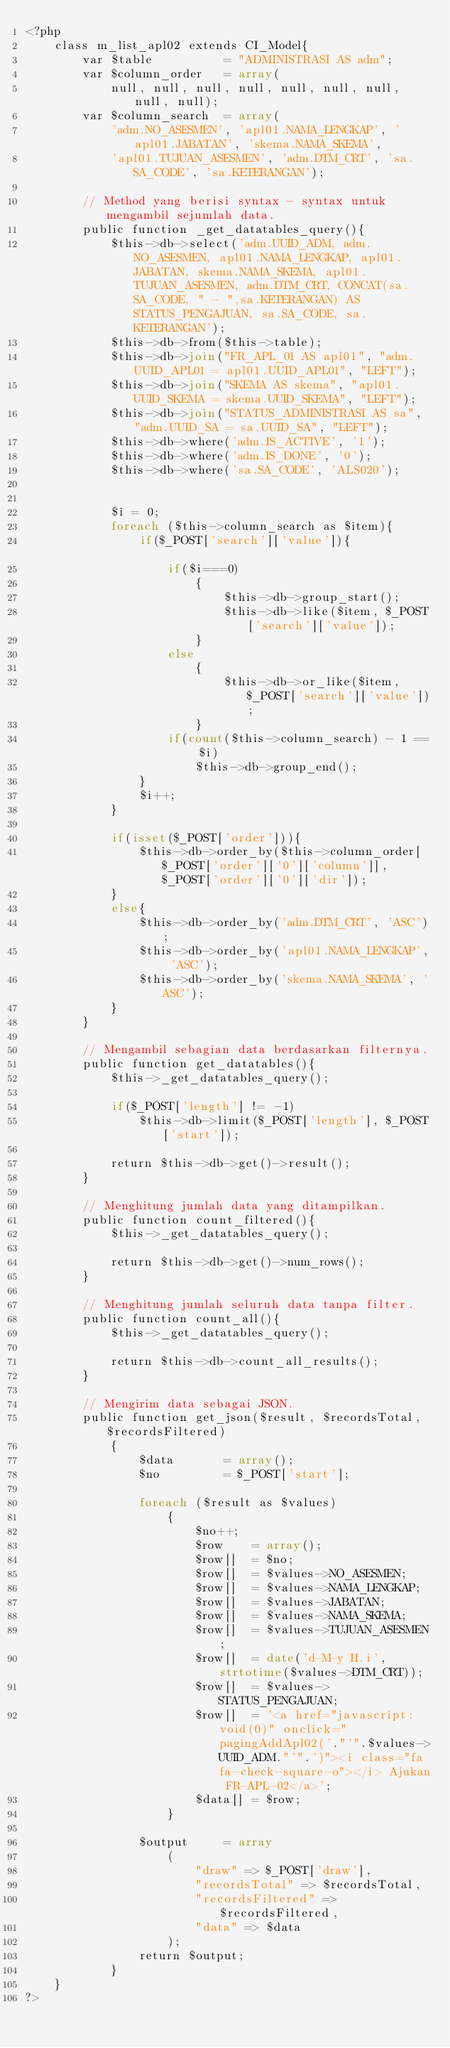<code> <loc_0><loc_0><loc_500><loc_500><_PHP_><?php
	class m_list_apl02 extends CI_Model{
		var $table			= "ADMINISTRASI AS adm";
		var $column_order	= array(
			null, null, null, null, null, null, null, null, null); 
		var $column_search	= array(
			'adm.NO_ASESMEN', 'apl01.NAMA_LENGKAP', 'apl01.JABATAN', 'skema.NAMA_SKEMA', 
			'apl01.TUJUAN_ASESMEN', 'adm.DTM_CRT', 'sa.SA_CODE', 'sa.KETERANGAN');
		
		// Method yang berisi syntax - syntax untuk mengambil sejumlah data.
		public function _get_datatables_query(){
			$this->db->select('adm.UUID_ADM, adm.NO_ASESMEN, apl01.NAMA_LENGKAP, apl01.JABATAN, skema.NAMA_SKEMA, apl01.TUJUAN_ASESMEN, adm.DTM_CRT, CONCAT(sa.SA_CODE, " - ",sa.KETERANGAN) AS STATUS_PENGAJUAN, sa.SA_CODE, sa.KETERANGAN');
			$this->db->from($this->table);
			$this->db->join("FR_APL_01 AS apl01", "adm.UUID_APL01 = apl01.UUID_APL01", "LEFT");
			$this->db->join("SKEMA AS skema", "apl01.UUID_SKEMA = skema.UUID_SKEMA", "LEFT");
			$this->db->join("STATUS_ADMINISTRASI AS sa", "adm.UUID_SA = sa.UUID_SA", "LEFT");
			$this->db->where('adm.IS_ACTIVE', '1');
			$this->db->where('adm.IS_DONE', '0');
			$this->db->where('sa.SA_CODE', 'ALS020');
			
			
			$i = 0;
			foreach ($this->column_search as $item){
				if($_POST['search']['value']){					
					if($i===0)
						{
							$this->db->group_start(); 
							$this->db->like($item, $_POST['search']['value']);
						}
					else
						{
							$this->db->or_like($item, $_POST['search']['value']);
						}
					if(count($this->column_search) - 1 == $i) 
						$this->db->group_end(); 
				}
				$i++;
			}		
			
			if(isset($_POST['order'])){
				$this->db->order_by($this->column_order[$_POST['order']['0']['column']], $_POST['order']['0']['dir']);
			} 
			else{
				$this->db->order_by('adm.DTM_CRT', 'ASC');
				$this->db->order_by('apl01.NAMA_LENGKAP', 'ASC');
				$this->db->order_by('skema.NAMA_SKEMA', 'ASC');
			}
		}

		// Mengambil sebagian data berdasarkan filternya.
		public function get_datatables(){
			$this->_get_datatables_query();
			
			if($_POST['length'] != -1)
				$this->db->limit($_POST['length'], $_POST['start']);
			
			return $this->db->get()->result();
		}

		// Menghitung jumlah data yang ditampilkan.
		public function count_filtered(){
			$this->_get_datatables_query();
			
			return $this->db->get()->num_rows();
		}

		// Menghitung jumlah seluruh data tanpa filter.
		public function count_all(){
			$this->_get_datatables_query();
			
			return $this->db->count_all_results();
		}
		
		// Mengirim data sebagai JSON.
		public function get_json($result, $recordsTotal, $recordsFiltered)
			{			
				$data 		= array();
				$no			= $_POST['start'];
				
				foreach ($result as $values) 
					{
						$no++;
						$row	= array();
						$row[]	= $no;
						$row[] 	= $values->NO_ASESMEN;
						$row[] 	= $values->NAMA_LENGKAP;
						$row[] 	= $values->JABATAN;
						$row[] 	= $values->NAMA_SKEMA;
						$row[] 	= $values->TUJUAN_ASESMEN;
						$row[] 	= date('d-M-y H.i', strtotime($values->DTM_CRT));
						$row[] 	= $values->STATUS_PENGAJUAN;
						$row[] 	= '<a href="javascript:void(0)" onclick="pagingAddApl02('."'".$values->UUID_ADM."'".')"><i class="fa fa-check-square-o"></i> Ajukan FR-APL-02</a>';
						$data[]	= $row;
					}
		
				$output 	= array
					(
						"draw" => $_POST['draw'],
						"recordsTotal" => $recordsTotal, 
						"recordsFiltered" => $recordsFiltered,
						"data" => $data
					);
				return $output;
			}			
	}
?></code> 